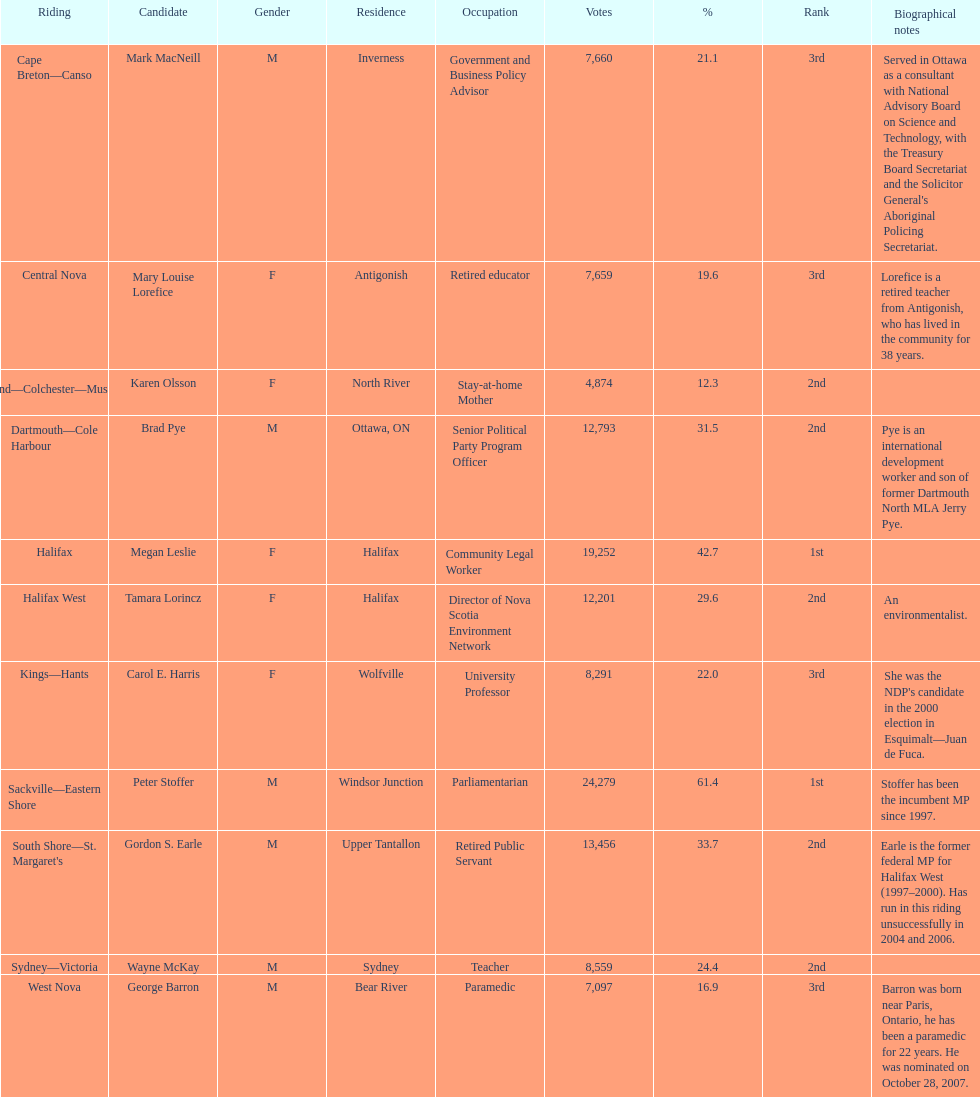Who got a larger number of votes, macneill or olsson? Mark MacNeill. 